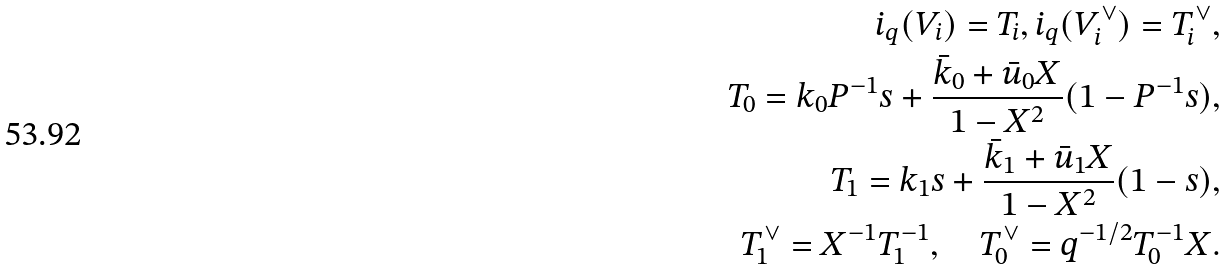Convert formula to latex. <formula><loc_0><loc_0><loc_500><loc_500>i _ { q } ( V _ { i } ) = T _ { i } , i _ { q } ( V ^ { \vee } _ { i } ) = T ^ { \vee } _ { i } , \\ T _ { 0 } = k _ { 0 } P ^ { - 1 } s + \frac { \bar { k } _ { 0 } + \bar { u } _ { 0 } X } { 1 - X ^ { 2 } } ( 1 - P ^ { - 1 } s ) , \\ T _ { 1 } = k _ { 1 } s + \frac { \bar { k } _ { 1 } + \bar { u } _ { 1 } X } { 1 - X ^ { 2 } } ( 1 - s ) , \\ T ^ { \vee } _ { 1 } = X ^ { - 1 } T _ { 1 } ^ { - 1 } , \quad T _ { 0 } ^ { \vee } = q ^ { - 1 / 2 } T _ { 0 } ^ { - 1 } X .</formula> 